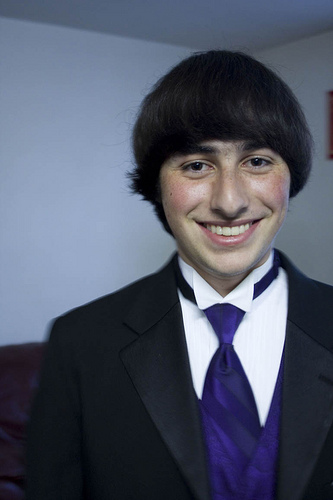<image>Which of the man's facial features are missing from this picture? I am not sure about the absent facial features of the man in the picture. It could be his beard or ears. What design does the man's tie have? I don't know what design the man's tie has. It might have stripes or be solid. What kind of business do you think this guy runs? I am not sure about the kind of business this person runs. The options are varied like school, tuxedo rental, law firm etc. Which of the man's facial features are missing from this picture? I don't know which of the man's facial features are missing from this picture. It can be seen that none of them are missing or it can be his ears. What design does the man's tie have? I am not sure what design the man's tie has. It can be seen as stripes, blue stripes, solid or swirls. What kind of business do you think this guy runs? I don't know what kind of business this guy runs. It could be a school, tuxedo rental, law firm, or something else. 